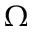<formula> <loc_0><loc_0><loc_500><loc_500>\Omega</formula> 